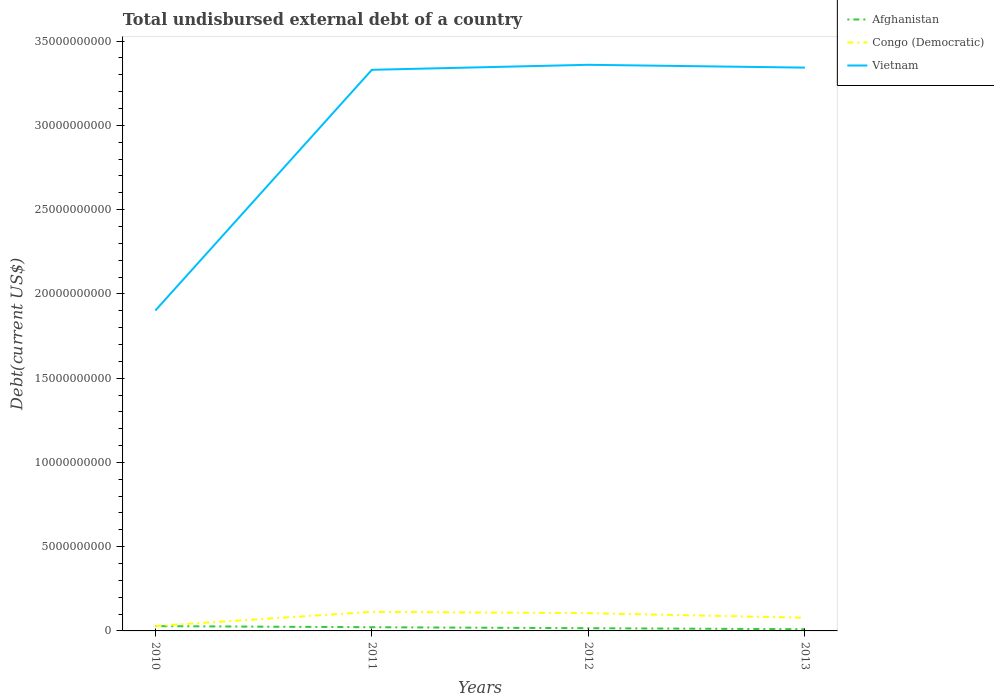How many different coloured lines are there?
Provide a short and direct response. 3. Across all years, what is the maximum total undisbursed external debt in Vietnam?
Your response must be concise. 1.90e+1. In which year was the total undisbursed external debt in Congo (Democratic) maximum?
Your answer should be compact. 2010. What is the total total undisbursed external debt in Vietnam in the graph?
Make the answer very short. -2.98e+08. What is the difference between the highest and the second highest total undisbursed external debt in Vietnam?
Your answer should be very brief. 1.46e+1. Is the total undisbursed external debt in Vietnam strictly greater than the total undisbursed external debt in Afghanistan over the years?
Keep it short and to the point. No. Does the graph contain any zero values?
Offer a terse response. No. Where does the legend appear in the graph?
Provide a short and direct response. Top right. What is the title of the graph?
Ensure brevity in your answer.  Total undisbursed external debt of a country. Does "Spain" appear as one of the legend labels in the graph?
Offer a terse response. No. What is the label or title of the Y-axis?
Your response must be concise. Debt(current US$). What is the Debt(current US$) of Afghanistan in 2010?
Ensure brevity in your answer.  2.84e+08. What is the Debt(current US$) in Congo (Democratic) in 2010?
Keep it short and to the point. 2.94e+08. What is the Debt(current US$) in Vietnam in 2010?
Offer a very short reply. 1.90e+1. What is the Debt(current US$) in Afghanistan in 2011?
Give a very brief answer. 2.20e+08. What is the Debt(current US$) of Congo (Democratic) in 2011?
Your response must be concise. 1.13e+09. What is the Debt(current US$) in Vietnam in 2011?
Give a very brief answer. 3.33e+1. What is the Debt(current US$) in Afghanistan in 2012?
Provide a succinct answer. 1.61e+08. What is the Debt(current US$) in Congo (Democratic) in 2012?
Ensure brevity in your answer.  1.05e+09. What is the Debt(current US$) in Vietnam in 2012?
Provide a succinct answer. 3.36e+1. What is the Debt(current US$) in Afghanistan in 2013?
Provide a succinct answer. 1.02e+08. What is the Debt(current US$) in Congo (Democratic) in 2013?
Provide a succinct answer. 7.83e+08. What is the Debt(current US$) in Vietnam in 2013?
Provide a succinct answer. 3.34e+1. Across all years, what is the maximum Debt(current US$) in Afghanistan?
Your answer should be very brief. 2.84e+08. Across all years, what is the maximum Debt(current US$) of Congo (Democratic)?
Make the answer very short. 1.13e+09. Across all years, what is the maximum Debt(current US$) of Vietnam?
Keep it short and to the point. 3.36e+1. Across all years, what is the minimum Debt(current US$) in Afghanistan?
Keep it short and to the point. 1.02e+08. Across all years, what is the minimum Debt(current US$) of Congo (Democratic)?
Give a very brief answer. 2.94e+08. Across all years, what is the minimum Debt(current US$) of Vietnam?
Offer a terse response. 1.90e+1. What is the total Debt(current US$) in Afghanistan in the graph?
Keep it short and to the point. 7.67e+08. What is the total Debt(current US$) in Congo (Democratic) in the graph?
Your answer should be compact. 3.26e+09. What is the total Debt(current US$) in Vietnam in the graph?
Offer a terse response. 1.19e+11. What is the difference between the Debt(current US$) in Afghanistan in 2010 and that in 2011?
Ensure brevity in your answer.  6.44e+07. What is the difference between the Debt(current US$) in Congo (Democratic) in 2010 and that in 2011?
Your answer should be compact. -8.38e+08. What is the difference between the Debt(current US$) of Vietnam in 2010 and that in 2011?
Offer a very short reply. -1.43e+1. What is the difference between the Debt(current US$) of Afghanistan in 2010 and that in 2012?
Your answer should be compact. 1.23e+08. What is the difference between the Debt(current US$) in Congo (Democratic) in 2010 and that in 2012?
Provide a short and direct response. -7.61e+08. What is the difference between the Debt(current US$) in Vietnam in 2010 and that in 2012?
Offer a very short reply. -1.46e+1. What is the difference between the Debt(current US$) in Afghanistan in 2010 and that in 2013?
Make the answer very short. 1.83e+08. What is the difference between the Debt(current US$) in Congo (Democratic) in 2010 and that in 2013?
Offer a very short reply. -4.89e+08. What is the difference between the Debt(current US$) of Vietnam in 2010 and that in 2013?
Your answer should be compact. -1.44e+1. What is the difference between the Debt(current US$) of Afghanistan in 2011 and that in 2012?
Make the answer very short. 5.87e+07. What is the difference between the Debt(current US$) of Congo (Democratic) in 2011 and that in 2012?
Make the answer very short. 7.69e+07. What is the difference between the Debt(current US$) of Vietnam in 2011 and that in 2012?
Your answer should be compact. -2.98e+08. What is the difference between the Debt(current US$) in Afghanistan in 2011 and that in 2013?
Provide a short and direct response. 1.18e+08. What is the difference between the Debt(current US$) of Congo (Democratic) in 2011 and that in 2013?
Ensure brevity in your answer.  3.49e+08. What is the difference between the Debt(current US$) of Vietnam in 2011 and that in 2013?
Your response must be concise. -1.31e+08. What is the difference between the Debt(current US$) of Afghanistan in 2012 and that in 2013?
Your answer should be compact. 5.97e+07. What is the difference between the Debt(current US$) in Congo (Democratic) in 2012 and that in 2013?
Provide a short and direct response. 2.72e+08. What is the difference between the Debt(current US$) in Vietnam in 2012 and that in 2013?
Provide a succinct answer. 1.67e+08. What is the difference between the Debt(current US$) of Afghanistan in 2010 and the Debt(current US$) of Congo (Democratic) in 2011?
Your answer should be compact. -8.47e+08. What is the difference between the Debt(current US$) of Afghanistan in 2010 and the Debt(current US$) of Vietnam in 2011?
Offer a very short reply. -3.30e+1. What is the difference between the Debt(current US$) in Congo (Democratic) in 2010 and the Debt(current US$) in Vietnam in 2011?
Make the answer very short. -3.30e+1. What is the difference between the Debt(current US$) in Afghanistan in 2010 and the Debt(current US$) in Congo (Democratic) in 2012?
Your answer should be very brief. -7.70e+08. What is the difference between the Debt(current US$) of Afghanistan in 2010 and the Debt(current US$) of Vietnam in 2012?
Keep it short and to the point. -3.33e+1. What is the difference between the Debt(current US$) of Congo (Democratic) in 2010 and the Debt(current US$) of Vietnam in 2012?
Keep it short and to the point. -3.33e+1. What is the difference between the Debt(current US$) in Afghanistan in 2010 and the Debt(current US$) in Congo (Democratic) in 2013?
Make the answer very short. -4.98e+08. What is the difference between the Debt(current US$) of Afghanistan in 2010 and the Debt(current US$) of Vietnam in 2013?
Provide a succinct answer. -3.31e+1. What is the difference between the Debt(current US$) of Congo (Democratic) in 2010 and the Debt(current US$) of Vietnam in 2013?
Ensure brevity in your answer.  -3.31e+1. What is the difference between the Debt(current US$) of Afghanistan in 2011 and the Debt(current US$) of Congo (Democratic) in 2012?
Provide a succinct answer. -8.35e+08. What is the difference between the Debt(current US$) of Afghanistan in 2011 and the Debt(current US$) of Vietnam in 2012?
Give a very brief answer. -3.34e+1. What is the difference between the Debt(current US$) in Congo (Democratic) in 2011 and the Debt(current US$) in Vietnam in 2012?
Provide a short and direct response. -3.25e+1. What is the difference between the Debt(current US$) in Afghanistan in 2011 and the Debt(current US$) in Congo (Democratic) in 2013?
Your answer should be compact. -5.63e+08. What is the difference between the Debt(current US$) in Afghanistan in 2011 and the Debt(current US$) in Vietnam in 2013?
Ensure brevity in your answer.  -3.32e+1. What is the difference between the Debt(current US$) of Congo (Democratic) in 2011 and the Debt(current US$) of Vietnam in 2013?
Make the answer very short. -3.23e+1. What is the difference between the Debt(current US$) in Afghanistan in 2012 and the Debt(current US$) in Congo (Democratic) in 2013?
Give a very brief answer. -6.21e+08. What is the difference between the Debt(current US$) in Afghanistan in 2012 and the Debt(current US$) in Vietnam in 2013?
Ensure brevity in your answer.  -3.33e+1. What is the difference between the Debt(current US$) of Congo (Democratic) in 2012 and the Debt(current US$) of Vietnam in 2013?
Make the answer very short. -3.24e+1. What is the average Debt(current US$) of Afghanistan per year?
Provide a short and direct response. 1.92e+08. What is the average Debt(current US$) in Congo (Democratic) per year?
Make the answer very short. 8.16e+08. What is the average Debt(current US$) in Vietnam per year?
Offer a very short reply. 2.98e+1. In the year 2010, what is the difference between the Debt(current US$) in Afghanistan and Debt(current US$) in Congo (Democratic)?
Ensure brevity in your answer.  -9.34e+06. In the year 2010, what is the difference between the Debt(current US$) in Afghanistan and Debt(current US$) in Vietnam?
Your answer should be very brief. -1.87e+1. In the year 2010, what is the difference between the Debt(current US$) in Congo (Democratic) and Debt(current US$) in Vietnam?
Your answer should be very brief. -1.87e+1. In the year 2011, what is the difference between the Debt(current US$) in Afghanistan and Debt(current US$) in Congo (Democratic)?
Your response must be concise. -9.11e+08. In the year 2011, what is the difference between the Debt(current US$) in Afghanistan and Debt(current US$) in Vietnam?
Ensure brevity in your answer.  -3.31e+1. In the year 2011, what is the difference between the Debt(current US$) in Congo (Democratic) and Debt(current US$) in Vietnam?
Your answer should be very brief. -3.22e+1. In the year 2012, what is the difference between the Debt(current US$) of Afghanistan and Debt(current US$) of Congo (Democratic)?
Provide a succinct answer. -8.93e+08. In the year 2012, what is the difference between the Debt(current US$) of Afghanistan and Debt(current US$) of Vietnam?
Give a very brief answer. -3.34e+1. In the year 2012, what is the difference between the Debt(current US$) of Congo (Democratic) and Debt(current US$) of Vietnam?
Keep it short and to the point. -3.25e+1. In the year 2013, what is the difference between the Debt(current US$) of Afghanistan and Debt(current US$) of Congo (Democratic)?
Keep it short and to the point. -6.81e+08. In the year 2013, what is the difference between the Debt(current US$) in Afghanistan and Debt(current US$) in Vietnam?
Provide a short and direct response. -3.33e+1. In the year 2013, what is the difference between the Debt(current US$) of Congo (Democratic) and Debt(current US$) of Vietnam?
Offer a very short reply. -3.26e+1. What is the ratio of the Debt(current US$) of Afghanistan in 2010 to that in 2011?
Provide a succinct answer. 1.29. What is the ratio of the Debt(current US$) of Congo (Democratic) in 2010 to that in 2011?
Offer a very short reply. 0.26. What is the ratio of the Debt(current US$) in Vietnam in 2010 to that in 2011?
Ensure brevity in your answer.  0.57. What is the ratio of the Debt(current US$) in Afghanistan in 2010 to that in 2012?
Provide a succinct answer. 1.76. What is the ratio of the Debt(current US$) in Congo (Democratic) in 2010 to that in 2012?
Offer a very short reply. 0.28. What is the ratio of the Debt(current US$) of Vietnam in 2010 to that in 2012?
Your response must be concise. 0.57. What is the ratio of the Debt(current US$) in Afghanistan in 2010 to that in 2013?
Give a very brief answer. 2.8. What is the ratio of the Debt(current US$) in Congo (Democratic) in 2010 to that in 2013?
Your response must be concise. 0.38. What is the ratio of the Debt(current US$) in Vietnam in 2010 to that in 2013?
Keep it short and to the point. 0.57. What is the ratio of the Debt(current US$) of Afghanistan in 2011 to that in 2012?
Make the answer very short. 1.36. What is the ratio of the Debt(current US$) of Congo (Democratic) in 2011 to that in 2012?
Provide a short and direct response. 1.07. What is the ratio of the Debt(current US$) of Vietnam in 2011 to that in 2012?
Your answer should be very brief. 0.99. What is the ratio of the Debt(current US$) of Afghanistan in 2011 to that in 2013?
Provide a succinct answer. 2.17. What is the ratio of the Debt(current US$) in Congo (Democratic) in 2011 to that in 2013?
Keep it short and to the point. 1.45. What is the ratio of the Debt(current US$) in Vietnam in 2011 to that in 2013?
Your answer should be compact. 1. What is the ratio of the Debt(current US$) in Afghanistan in 2012 to that in 2013?
Ensure brevity in your answer.  1.59. What is the ratio of the Debt(current US$) of Congo (Democratic) in 2012 to that in 2013?
Provide a succinct answer. 1.35. What is the difference between the highest and the second highest Debt(current US$) in Afghanistan?
Your response must be concise. 6.44e+07. What is the difference between the highest and the second highest Debt(current US$) in Congo (Democratic)?
Make the answer very short. 7.69e+07. What is the difference between the highest and the second highest Debt(current US$) of Vietnam?
Make the answer very short. 1.67e+08. What is the difference between the highest and the lowest Debt(current US$) in Afghanistan?
Offer a terse response. 1.83e+08. What is the difference between the highest and the lowest Debt(current US$) of Congo (Democratic)?
Give a very brief answer. 8.38e+08. What is the difference between the highest and the lowest Debt(current US$) in Vietnam?
Provide a succinct answer. 1.46e+1. 